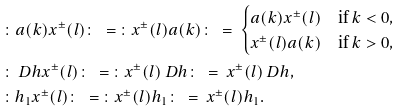<formula> <loc_0><loc_0><loc_500><loc_500>& \colon a ( k ) x ^ { \pm } ( l ) \colon \ = \ \colon x ^ { \pm } ( l ) a ( k ) \colon \ = \ \begin{cases} a ( k ) x ^ { \pm } ( l ) & \text {if $k<0$} , \\ x ^ { \pm } ( l ) a ( k ) & \text {if $k>0$} , \end{cases} \\ & \colon \ D h x ^ { \pm } ( l ) \colon \ = \ \colon x ^ { \pm } ( l ) \ D h \colon \ = \ x ^ { \pm } ( l ) \ D h , \\ & \colon h _ { 1 } x ^ { \pm } ( l ) \colon \ = \ \colon x ^ { \pm } ( l ) h _ { 1 } \colon \ = \ x ^ { \pm } ( l ) h _ { 1 } .</formula> 